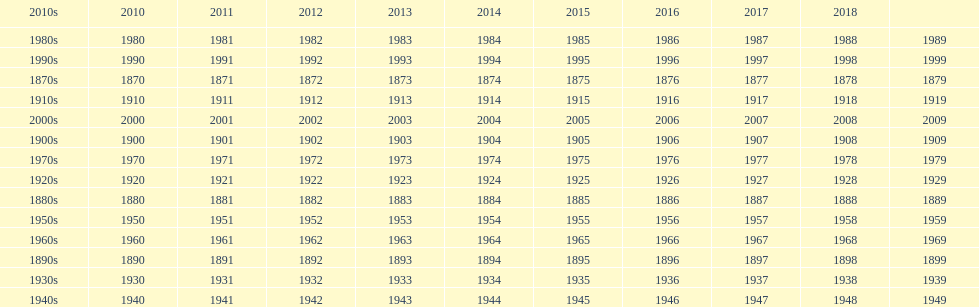True/false: all years go in consecutive order? True. 